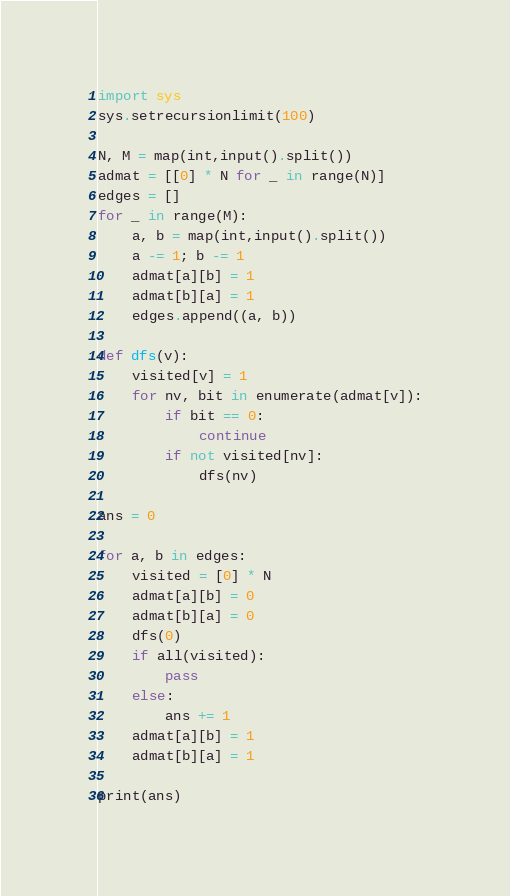<code> <loc_0><loc_0><loc_500><loc_500><_Python_>import sys
sys.setrecursionlimit(100)

N, M = map(int,input().split())
admat = [[0] * N for _ in range(N)]
edges = []
for _ in range(M):
    a, b = map(int,input().split())
    a -= 1; b -= 1
    admat[a][b] = 1
    admat[b][a] = 1
    edges.append((a, b))

def dfs(v):
    visited[v] = 1
    for nv, bit in enumerate(admat[v]):
        if bit == 0:
            continue
        if not visited[nv]:
            dfs(nv)

ans = 0

for a, b in edges:
    visited = [0] * N
    admat[a][b] = 0
    admat[b][a] = 0
    dfs(0)
    if all(visited):
        pass
    else:
        ans += 1
    admat[a][b] = 1
    admat[b][a] = 1

print(ans)</code> 